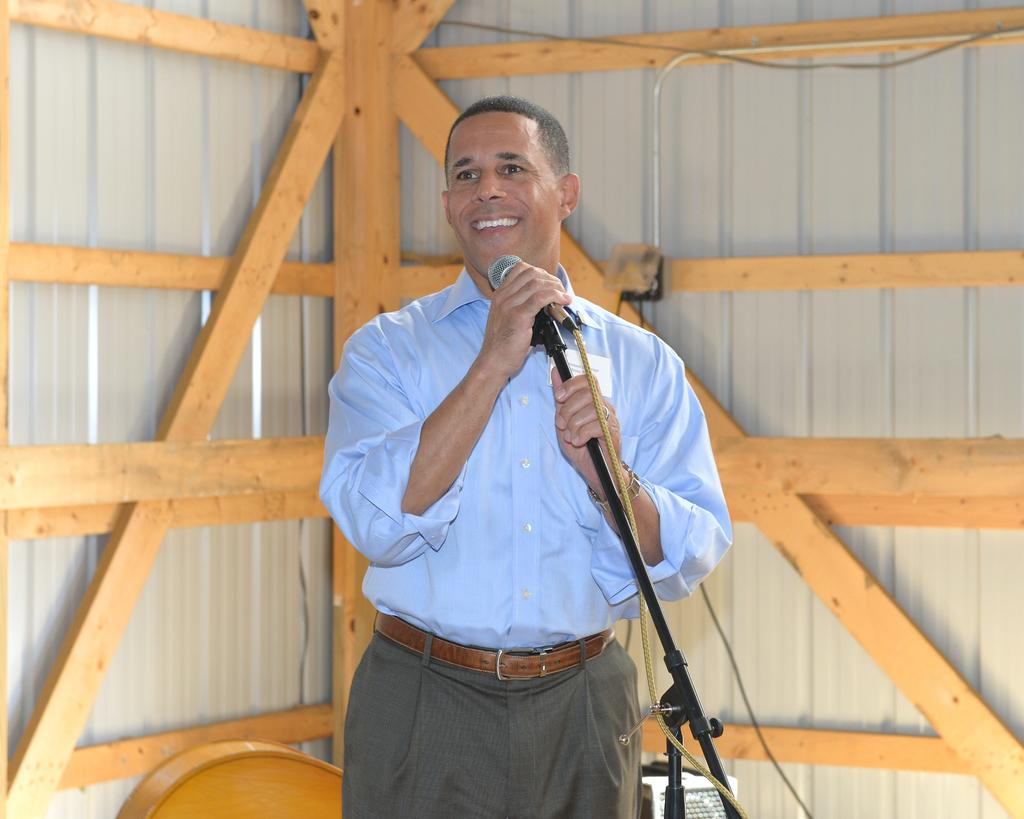What is the main subject of the image? There is a person in the image. What is the person wearing? The person is wearing a shirt. What is the person holding in the image? The person is holding a microphone with a stand. What is the person's posture in the image? The person is standing. What is the person's facial expression in the image? The person is smiling. What can be seen in the background of the image? There are wooden frames and a wall in the background of the image. What type of market is visible in the image? There is no market visible in the image; it features a person holding a microphone with a stand. What word is written on the wall in the image? There is no word written on the wall in the image; it only shows a person and wooden frames in the background. 